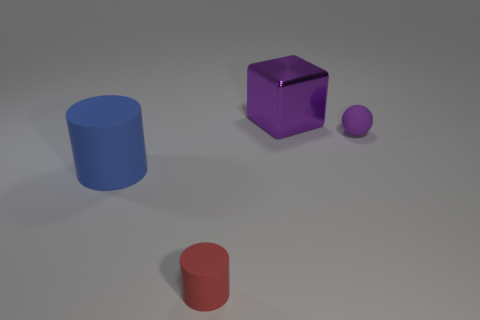Add 4 blue matte cylinders. How many objects exist? 8 Subtract all cubes. How many objects are left? 3 Add 2 tiny red rubber cylinders. How many tiny red rubber cylinders exist? 3 Subtract 0 red cubes. How many objects are left? 4 Subtract all large purple objects. Subtract all big blue matte things. How many objects are left? 2 Add 3 small things. How many small things are left? 5 